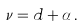<formula> <loc_0><loc_0><loc_500><loc_500>\nu = d + \alpha \, .</formula> 